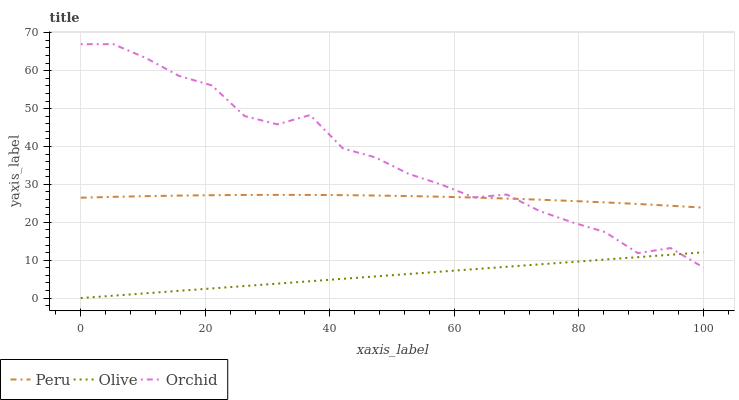Does Olive have the minimum area under the curve?
Answer yes or no. Yes. Does Orchid have the maximum area under the curve?
Answer yes or no. Yes. Does Peru have the minimum area under the curve?
Answer yes or no. No. Does Peru have the maximum area under the curve?
Answer yes or no. No. Is Olive the smoothest?
Answer yes or no. Yes. Is Orchid the roughest?
Answer yes or no. Yes. Is Peru the smoothest?
Answer yes or no. No. Is Peru the roughest?
Answer yes or no. No. Does Olive have the lowest value?
Answer yes or no. Yes. Does Orchid have the lowest value?
Answer yes or no. No. Does Orchid have the highest value?
Answer yes or no. Yes. Does Peru have the highest value?
Answer yes or no. No. Is Olive less than Peru?
Answer yes or no. Yes. Is Peru greater than Olive?
Answer yes or no. Yes. Does Orchid intersect Olive?
Answer yes or no. Yes. Is Orchid less than Olive?
Answer yes or no. No. Is Orchid greater than Olive?
Answer yes or no. No. Does Olive intersect Peru?
Answer yes or no. No. 